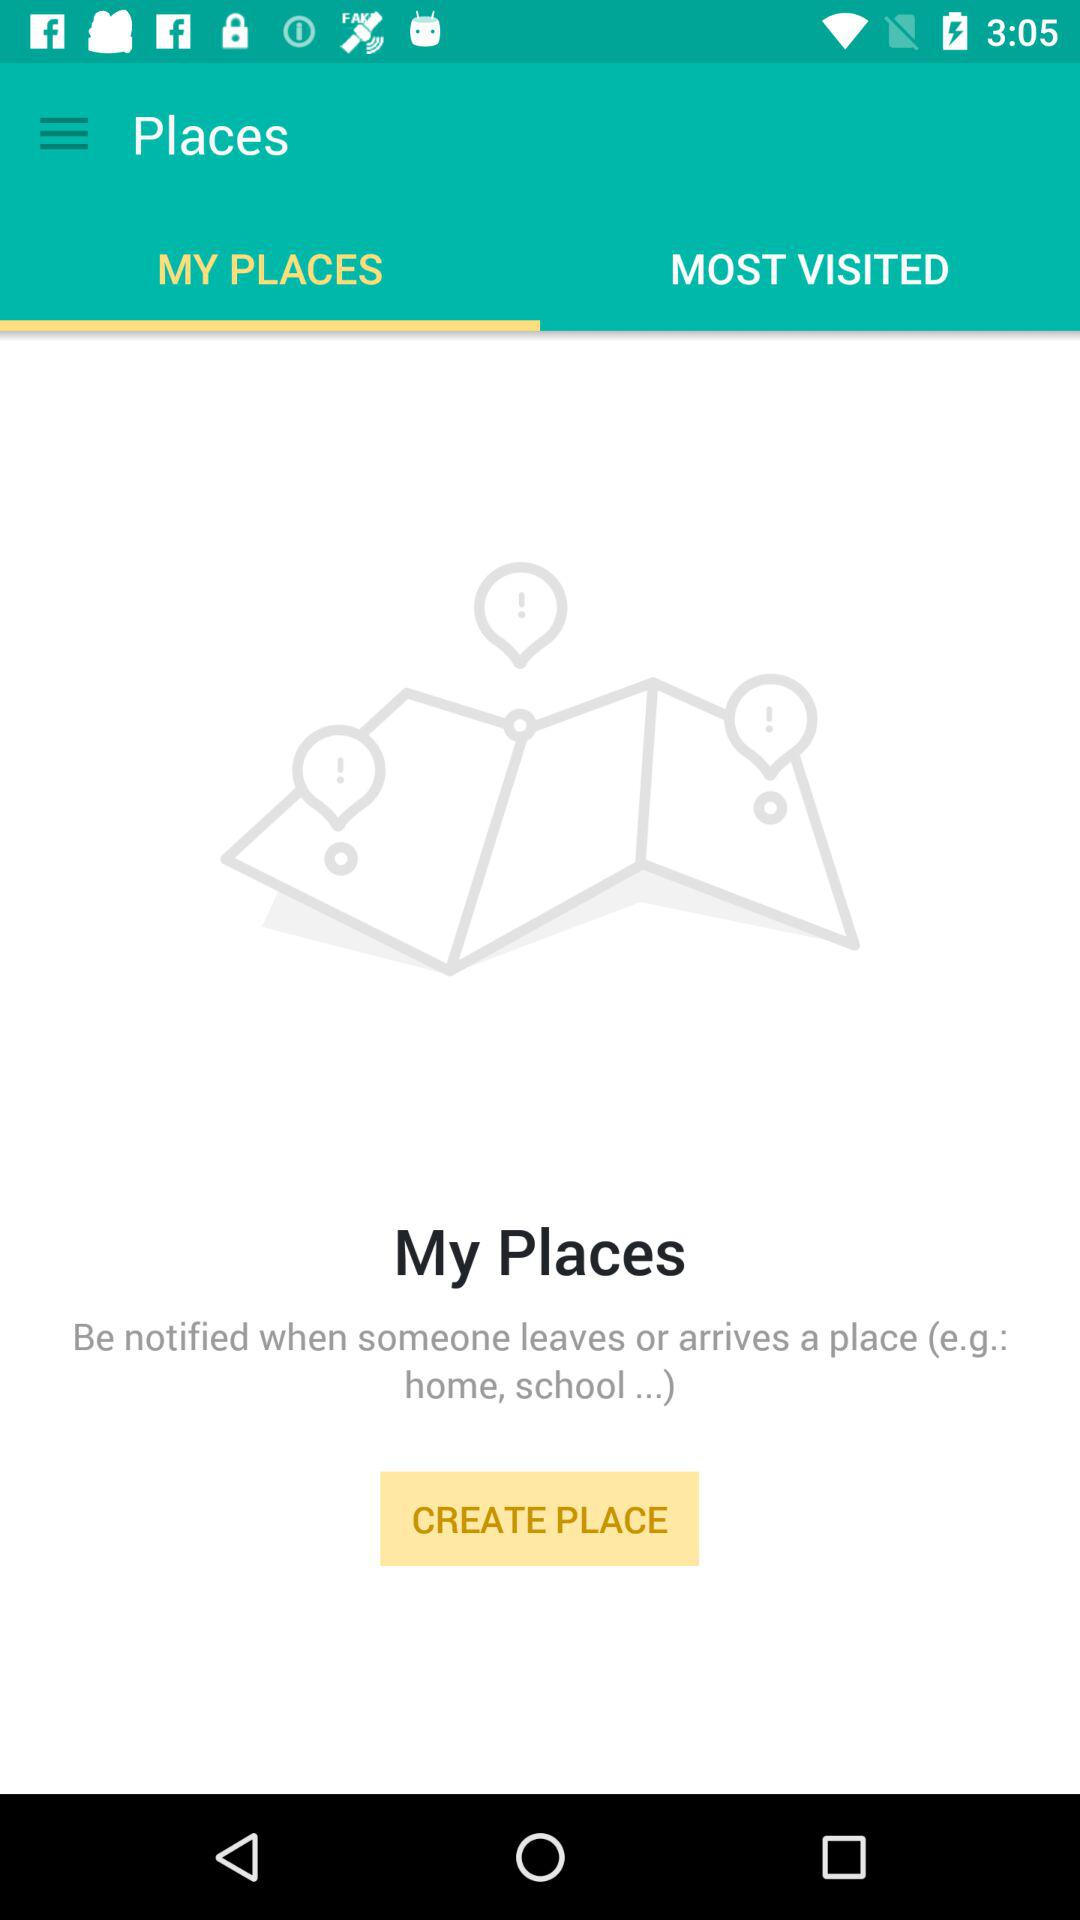Which tab is selected? The selected tab is "MY PLACES". 